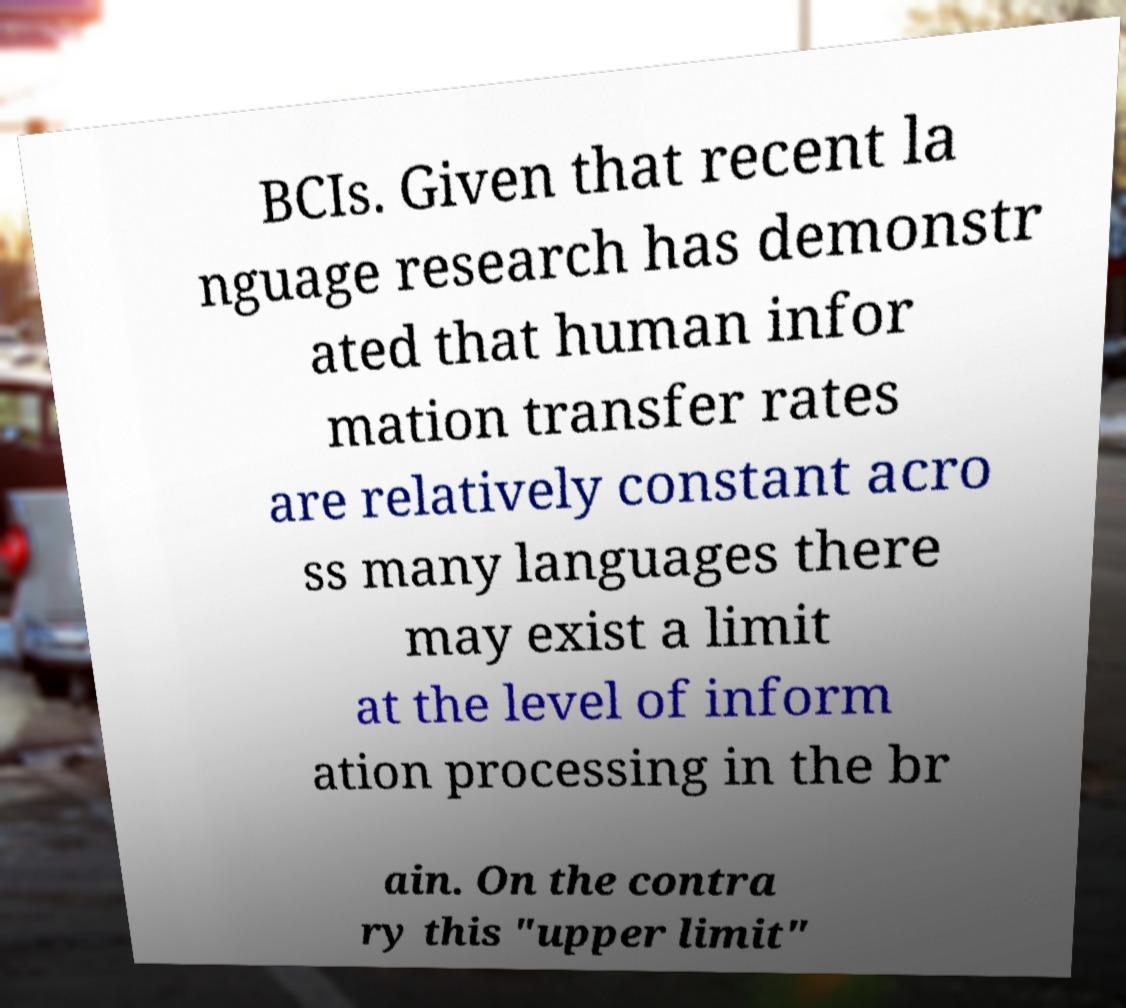Please read and relay the text visible in this image. What does it say? BCIs. Given that recent la nguage research has demonstr ated that human infor mation transfer rates are relatively constant acro ss many languages there may exist a limit at the level of inform ation processing in the br ain. On the contra ry this "upper limit" 